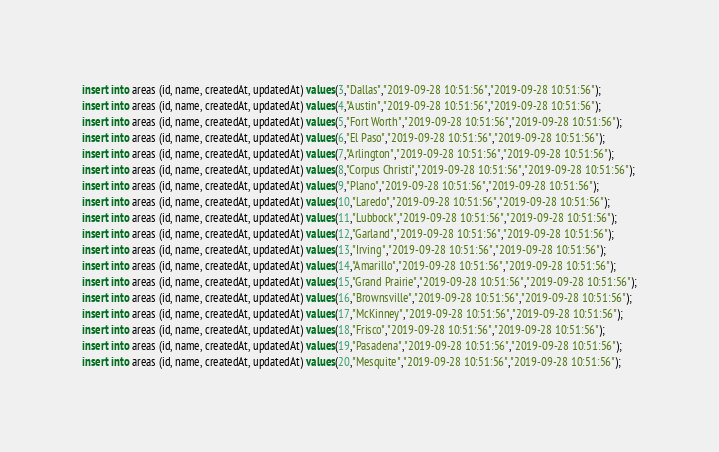Convert code to text. <code><loc_0><loc_0><loc_500><loc_500><_SQL_>insert into areas (id, name, createdAt, updatedAt) values(3,"Dallas","2019-09-28 10:51:56","2019-09-28 10:51:56");
insert into areas (id, name, createdAt, updatedAt) values(4,"Austin","2019-09-28 10:51:56","2019-09-28 10:51:56");
insert into areas (id, name, createdAt, updatedAt) values(5,"Fort Worth","2019-09-28 10:51:56","2019-09-28 10:51:56");
insert into areas (id, name, createdAt, updatedAt) values(6,"El Paso","2019-09-28 10:51:56","2019-09-28 10:51:56");
insert into areas (id, name, createdAt, updatedAt) values(7,"Arlington","2019-09-28 10:51:56","2019-09-28 10:51:56");
insert into areas (id, name, createdAt, updatedAt) values(8,"Corpus Christi","2019-09-28 10:51:56","2019-09-28 10:51:56");
insert into areas (id, name, createdAt, updatedAt) values(9,"Plano","2019-09-28 10:51:56","2019-09-28 10:51:56");
insert into areas (id, name, createdAt, updatedAt) values(10,"Laredo","2019-09-28 10:51:56","2019-09-28 10:51:56");
insert into areas (id, name, createdAt, updatedAt) values(11,"Lubbock","2019-09-28 10:51:56","2019-09-28 10:51:56");
insert into areas (id, name, createdAt, updatedAt) values(12,"Garland","2019-09-28 10:51:56","2019-09-28 10:51:56");
insert into areas (id, name, createdAt, updatedAt) values(13,"Irving","2019-09-28 10:51:56","2019-09-28 10:51:56");
insert into areas (id, name, createdAt, updatedAt) values(14,"Amarillo","2019-09-28 10:51:56","2019-09-28 10:51:56");
insert into areas (id, name, createdAt, updatedAt) values(15,"Grand Prairie","2019-09-28 10:51:56","2019-09-28 10:51:56");
insert into areas (id, name, createdAt, updatedAt) values(16,"Brownsville","2019-09-28 10:51:56","2019-09-28 10:51:56");
insert into areas (id, name, createdAt, updatedAt) values(17,"McKinney","2019-09-28 10:51:56","2019-09-28 10:51:56");
insert into areas (id, name, createdAt, updatedAt) values(18,"Frisco","2019-09-28 10:51:56","2019-09-28 10:51:56");
insert into areas (id, name, createdAt, updatedAt) values(19,"Pasadena","2019-09-28 10:51:56","2019-09-28 10:51:56");
insert into areas (id, name, createdAt, updatedAt) values(20,"Mesquite","2019-09-28 10:51:56","2019-09-28 10:51:56");</code> 